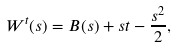Convert formula to latex. <formula><loc_0><loc_0><loc_500><loc_500>W ^ { t } ( s ) = B ( s ) + s t - \frac { s ^ { 2 } } { 2 } ,</formula> 